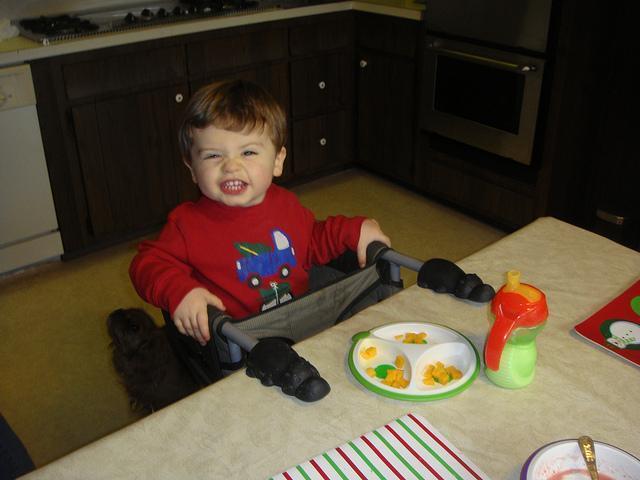How many dining tables are there?
Give a very brief answer. 1. 